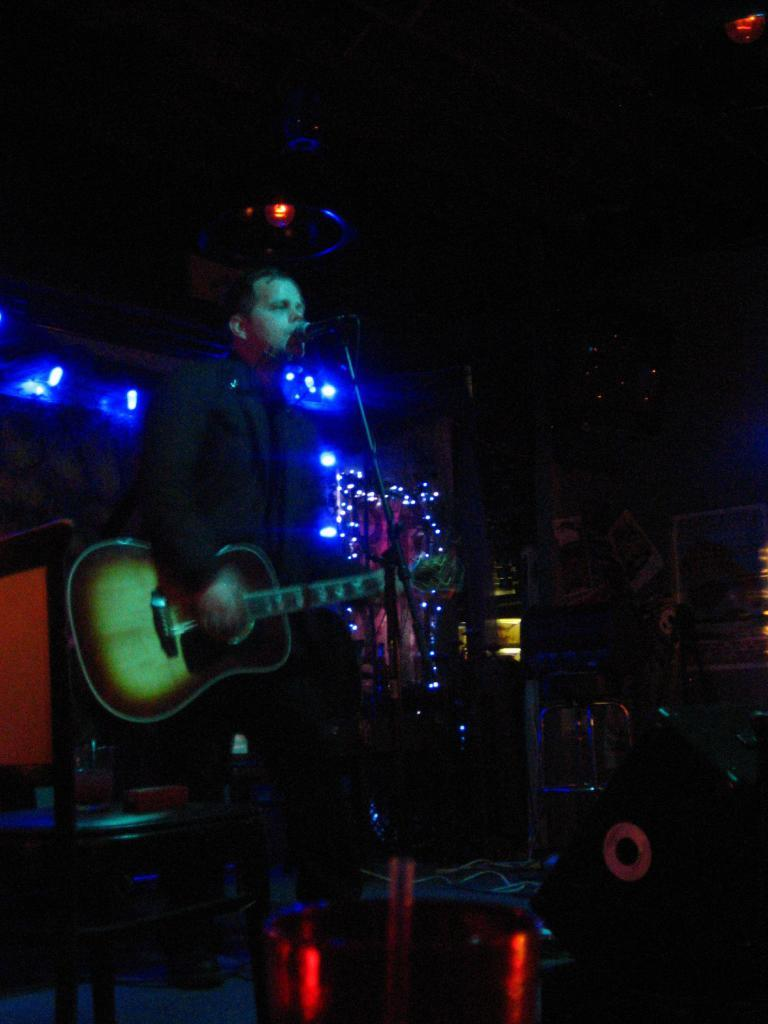What is the man in the image doing? The man is playing a guitar and singing. What object is in front of the man? There is a microphone in front of the man. What can be seen behind the man? Colorful lights are visible behind the man. What type of button is the man wearing on his shirt in the image? There is no mention of a button on the man's shirt in the image. Can you tell me how many cameras are visible in the image? There is no camera visible in the image. Is the man holding a kite in the image? There is no kite present in the image. 